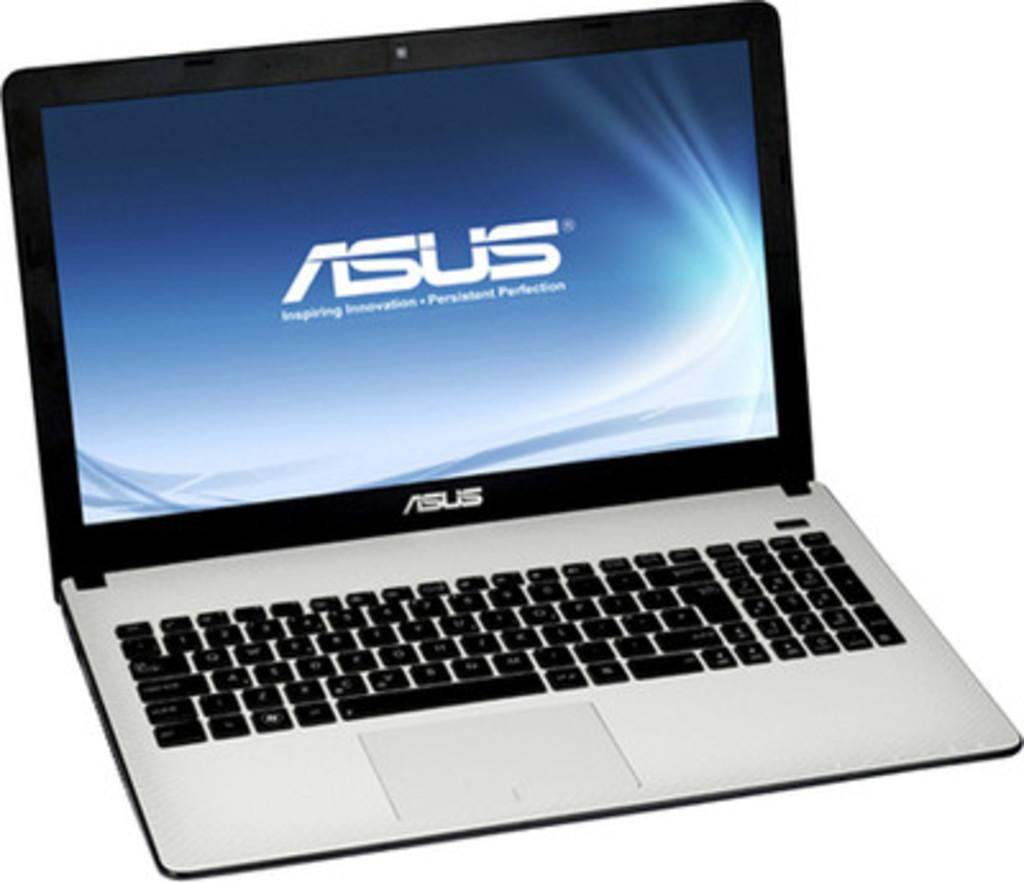What electronic device is visible in the image? There is a laptop in the image. Can you describe the appearance of the laptop? The laptop appears to be a standard laptop with a screen and keyboard. What might someone be doing with the laptop in the image? It is not clear what the person is doing with the laptop, but they may be using it for work, browsing the internet, or other activities. Where is the nest located in the image? There is no nest present in the image; it only features a laptop. 